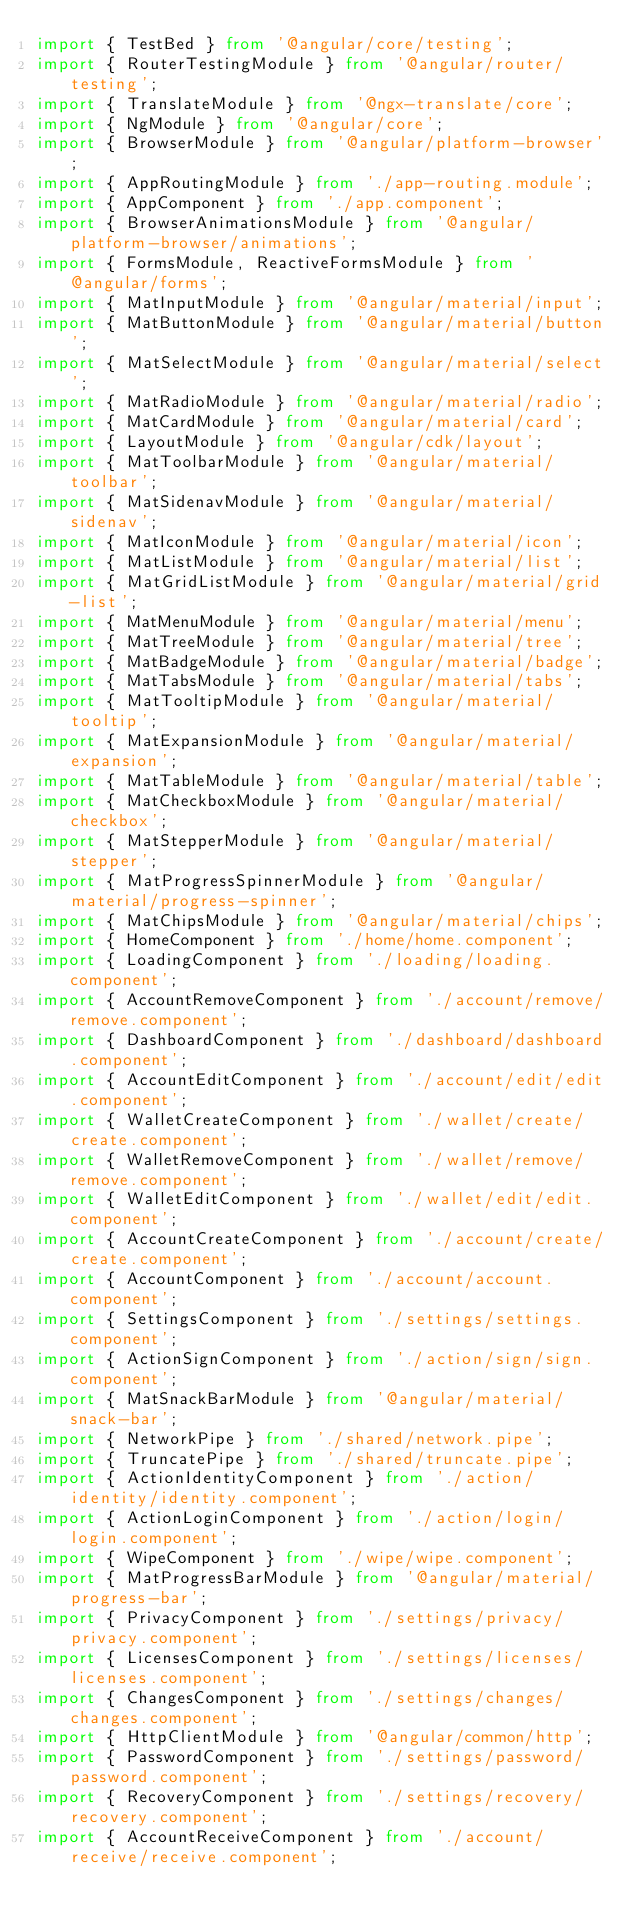<code> <loc_0><loc_0><loc_500><loc_500><_TypeScript_>import { TestBed } from '@angular/core/testing';
import { RouterTestingModule } from '@angular/router/testing';
import { TranslateModule } from '@ngx-translate/core';
import { NgModule } from '@angular/core';
import { BrowserModule } from '@angular/platform-browser';
import { AppRoutingModule } from './app-routing.module';
import { AppComponent } from './app.component';
import { BrowserAnimationsModule } from '@angular/platform-browser/animations';
import { FormsModule, ReactiveFormsModule } from '@angular/forms';
import { MatInputModule } from '@angular/material/input';
import { MatButtonModule } from '@angular/material/button';
import { MatSelectModule } from '@angular/material/select';
import { MatRadioModule } from '@angular/material/radio';
import { MatCardModule } from '@angular/material/card';
import { LayoutModule } from '@angular/cdk/layout';
import { MatToolbarModule } from '@angular/material/toolbar';
import { MatSidenavModule } from '@angular/material/sidenav';
import { MatIconModule } from '@angular/material/icon';
import { MatListModule } from '@angular/material/list';
import { MatGridListModule } from '@angular/material/grid-list';
import { MatMenuModule } from '@angular/material/menu';
import { MatTreeModule } from '@angular/material/tree';
import { MatBadgeModule } from '@angular/material/badge';
import { MatTabsModule } from '@angular/material/tabs';
import { MatTooltipModule } from '@angular/material/tooltip';
import { MatExpansionModule } from '@angular/material/expansion';
import { MatTableModule } from '@angular/material/table';
import { MatCheckboxModule } from '@angular/material/checkbox';
import { MatStepperModule } from '@angular/material/stepper';
import { MatProgressSpinnerModule } from '@angular/material/progress-spinner';
import { MatChipsModule } from '@angular/material/chips';
import { HomeComponent } from './home/home.component';
import { LoadingComponent } from './loading/loading.component';
import { AccountRemoveComponent } from './account/remove/remove.component';
import { DashboardComponent } from './dashboard/dashboard.component';
import { AccountEditComponent } from './account/edit/edit.component';
import { WalletCreateComponent } from './wallet/create/create.component';
import { WalletRemoveComponent } from './wallet/remove/remove.component';
import { WalletEditComponent } from './wallet/edit/edit.component';
import { AccountCreateComponent } from './account/create/create.component';
import { AccountComponent } from './account/account.component';
import { SettingsComponent } from './settings/settings.component';
import { ActionSignComponent } from './action/sign/sign.component';
import { MatSnackBarModule } from '@angular/material/snack-bar';
import { NetworkPipe } from './shared/network.pipe';
import { TruncatePipe } from './shared/truncate.pipe';
import { ActionIdentityComponent } from './action/identity/identity.component';
import { ActionLoginComponent } from './action/login/login.component';
import { WipeComponent } from './wipe/wipe.component';
import { MatProgressBarModule } from '@angular/material/progress-bar';
import { PrivacyComponent } from './settings/privacy/privacy.component';
import { LicensesComponent } from './settings/licenses/licenses.component';
import { ChangesComponent } from './settings/changes/changes.component';
import { HttpClientModule } from '@angular/common/http';
import { PasswordComponent } from './settings/password/password.component';
import { RecoveryComponent } from './settings/recovery/recovery.component';
import { AccountReceiveComponent } from './account/receive/receive.component';</code> 